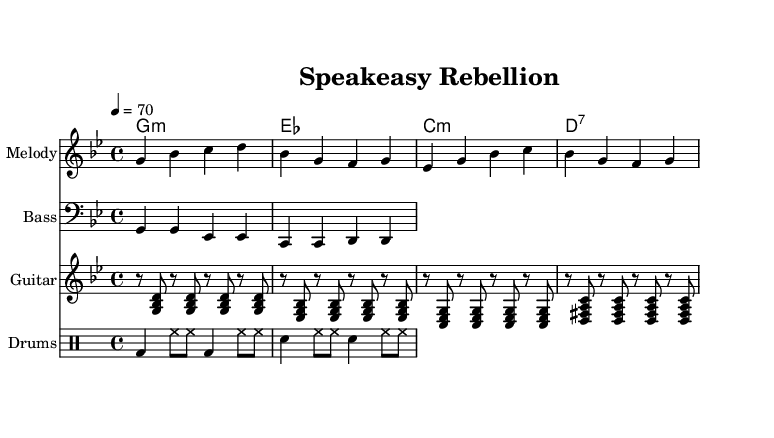What is the key signature of this music? The key signature is G minor, which has two flats (B flat and E flat). This is indicated at the beginning of the staff.
Answer: G minor What is the time signature of the piece? The time signature is 4/4, which means there are four beats per measure. This is shown at the beginning of the score.
Answer: 4/4 What is the tempo marking for this composition? The tempo marking indicates a speed of 70 beats per minute, as specified by "4 = 70" at the beginning.
Answer: 70 How many measures are there in the melody? By counting the segments between the bar lines, we find there are a total of 8 measures in the melody section.
Answer: 8 What is the first chord used in the chord progression? The first chord in the progression is G minor, which is indicated in the chord names section aligned with the melody.
Answer: G minor What type of guitar strumming pattern is prominent in the piece? The rhythm guitar employs a distinct strumming pattern characterized by eighth-note chords that create a steady groove, typical in reggae.
Answer: Steady groove How does the drum pattern contribute to the reggae feel? The drum pattern uses a bass drum and snare combination that emphasizes the off-beat, creating a laid-back groove that is fundamental to reggae music.
Answer: Off-beat 